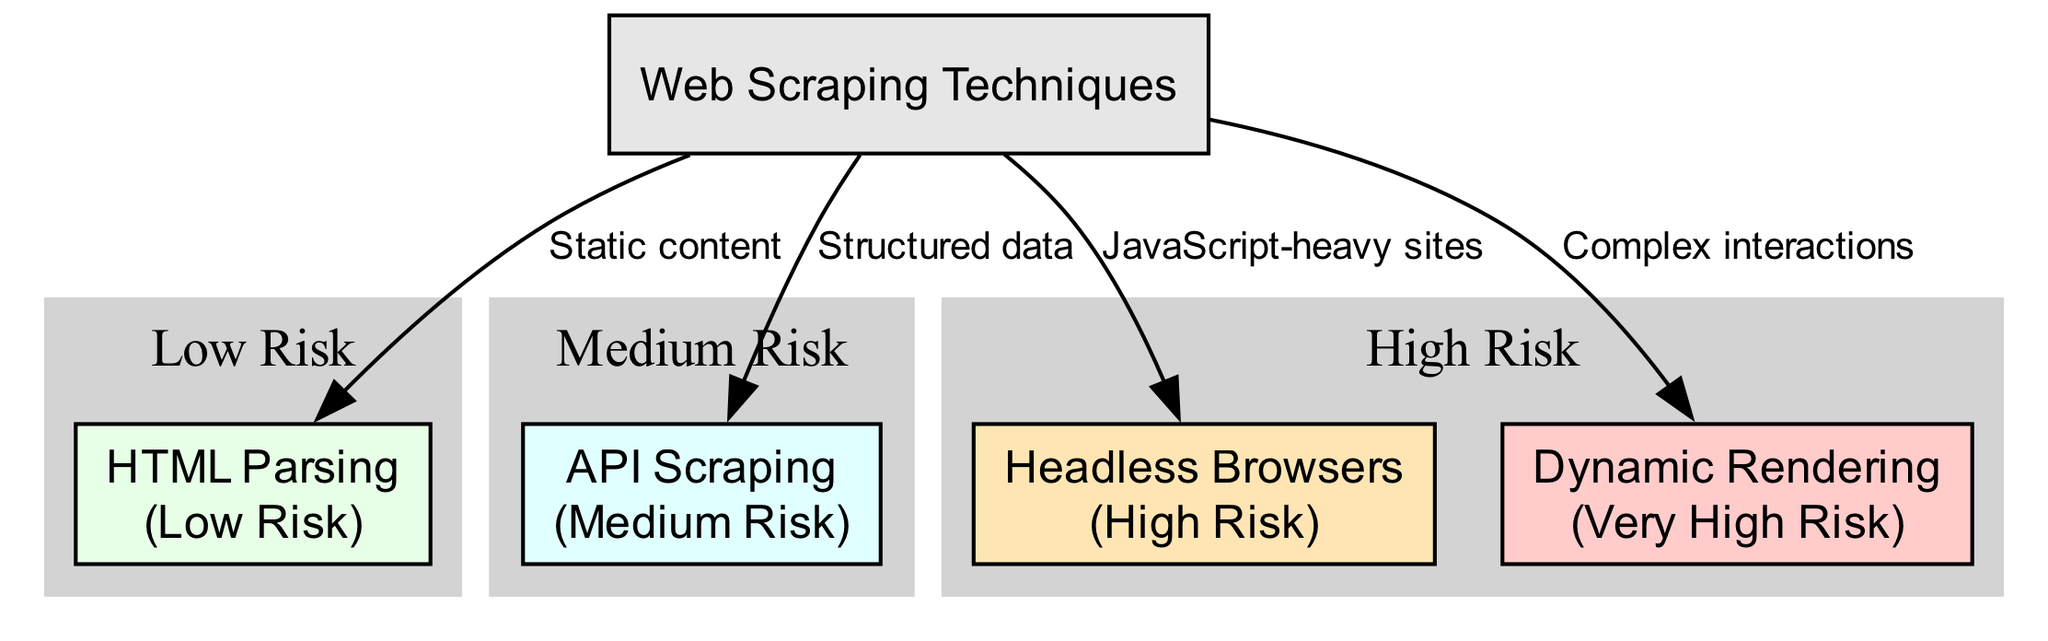What is the highest risk web scraping technique shown in the diagram? The diagram lists various web scraping techniques and their associated risk levels. The technique labeled "Dynamic Rendering" is highlighted with a risk level of "Very High."
Answer: Dynamic Rendering How many techniques are categorized as having high risk? The diagram categorizes different techniques based on their risk levels. The high risk category includes "Headless Browsers" and "Dynamic Rendering," totaling two techniques.
Answer: 2 What type of content is "HTML Parsing" associated with? In the diagram, "HTML Parsing" is linked to static content, showing its applicability to data extraction from static web pages.
Answer: Static content Which web scraping technique is linked to complex interactions? The diagram indicates that "Dynamic Rendering" is connected to complex interactions, suggesting its use in situations that involve advanced user interactions on websites.
Answer: Dynamic Rendering Which cluster contains nodes associated with low risk? The diagram includes a cluster labeled "Low Risk." The only node in this cluster is "HTML Parsing," which indicates that it is deemed to have a low level of risk in web scraping.
Answer: Low Risk What is the risk level of API Scraping according to the diagram? The diagram identifies the risk level of "API Scraping" as "Medium," indicating that while it is not the safest option, it is less risky than others like "Headless Browsers" or "Dynamic Rendering."
Answer: Medium How many edges connect the root node to the techniques? The diagram displays four edges leading from the "Web Scraping Techniques" root node to its corresponding techniques, representing the different paths of scraping methods.
Answer: 4 What is the relationship between "Headless Browsers" and risk level? The diagram explicitly categorizes "Headless Browsers" under the high-risk cluster, indicating its potential legal implications and risks associated with its usage in web scraping.
Answer: High Risk Which web scraping technique has the lowest risk? The diagram shows "HTML Parsing" as the only technique classified in the low-risk category, signifying it poses the least threat among the techniques presented.
Answer: HTML Parsing 